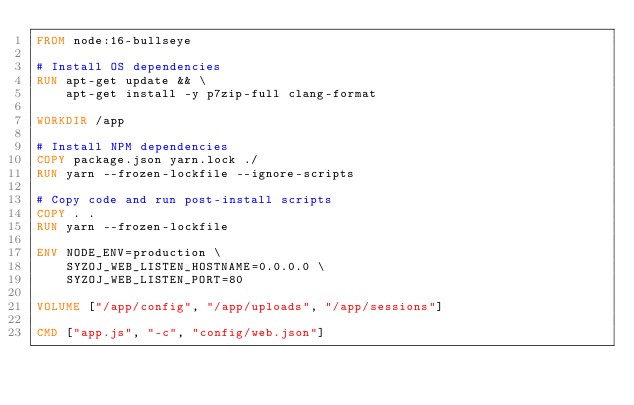Convert code to text. <code><loc_0><loc_0><loc_500><loc_500><_Dockerfile_>FROM node:16-bullseye

# Install OS dependencies
RUN apt-get update && \
    apt-get install -y p7zip-full clang-format

WORKDIR /app

# Install NPM dependencies
COPY package.json yarn.lock ./
RUN yarn --frozen-lockfile --ignore-scripts

# Copy code and run post-install scripts
COPY . .
RUN yarn --frozen-lockfile

ENV NODE_ENV=production \
    SYZOJ_WEB_LISTEN_HOSTNAME=0.0.0.0 \
    SYZOJ_WEB_LISTEN_PORT=80

VOLUME ["/app/config", "/app/uploads", "/app/sessions"]

CMD ["app.js", "-c", "config/web.json"]
</code> 